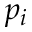<formula> <loc_0><loc_0><loc_500><loc_500>p _ { i }</formula> 